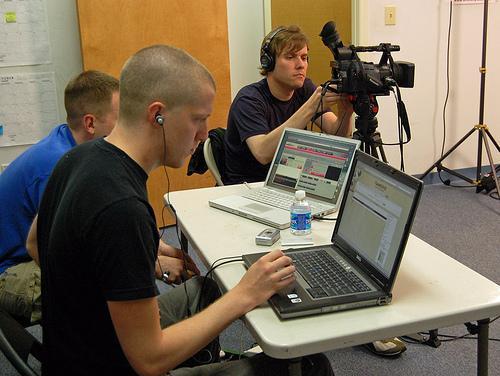How many people in the picture?
Give a very brief answer. 3. How many men are here?
Give a very brief answer. 3. How many people are using headphones?
Give a very brief answer. 2. How many men are there?
Give a very brief answer. 3. How many computers are in this picture?
Give a very brief answer. 2. How many laptops are on the table?
Give a very brief answer. 2. How many laptops are there?
Give a very brief answer. 2. How many people?
Give a very brief answer. 3. How many people are there?
Give a very brief answer. 3. 